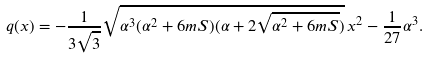<formula> <loc_0><loc_0><loc_500><loc_500>q ( x ) = - \frac { 1 } { 3 \sqrt { 3 } } \sqrt { \alpha ^ { 3 } ( \alpha ^ { 2 } + 6 m S ) ( \alpha + 2 \sqrt { \alpha ^ { 2 } + 6 m S } ) } \, x ^ { 2 } - \frac { 1 } { 2 7 } \alpha ^ { 3 } .</formula> 